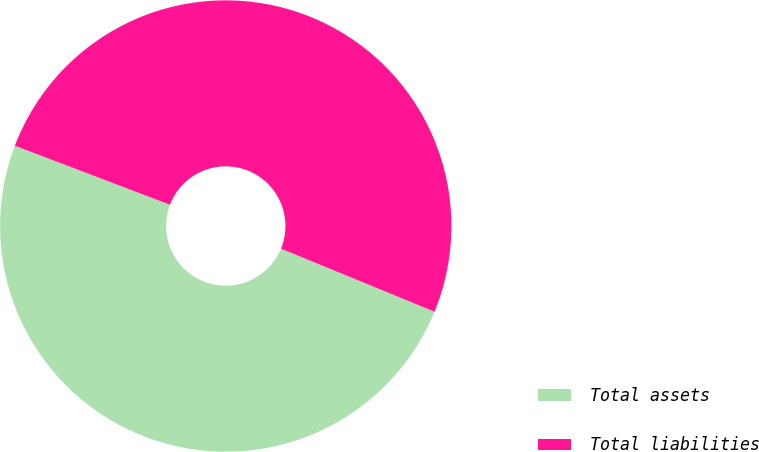<chart> <loc_0><loc_0><loc_500><loc_500><pie_chart><fcel>Total assets<fcel>Total liabilities<nl><fcel>49.59%<fcel>50.41%<nl></chart> 